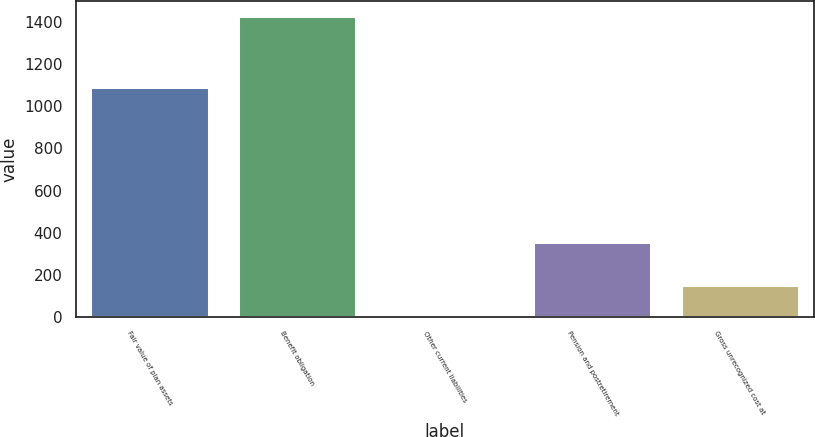<chart> <loc_0><loc_0><loc_500><loc_500><bar_chart><fcel>Fair value of plan assets<fcel>Benefit obligation<fcel>Other current liabilities<fcel>Pension and postretirement<fcel>Gross unrecognized cost at<nl><fcel>1092<fcel>1425<fcel>3<fcel>358<fcel>153<nl></chart> 